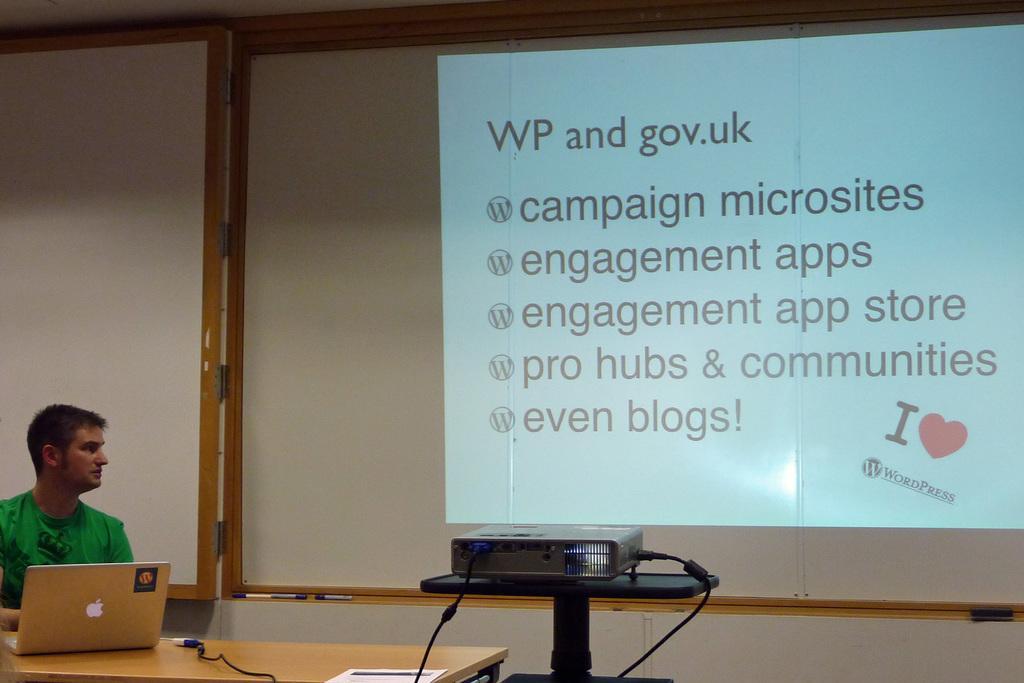Please provide a concise description of this image. In this image there is a table, on that table there is a laptop, in front of the table there is a man sitting on chair, beside the table there is a stand on that stand there is a projector projecting on a wall. 